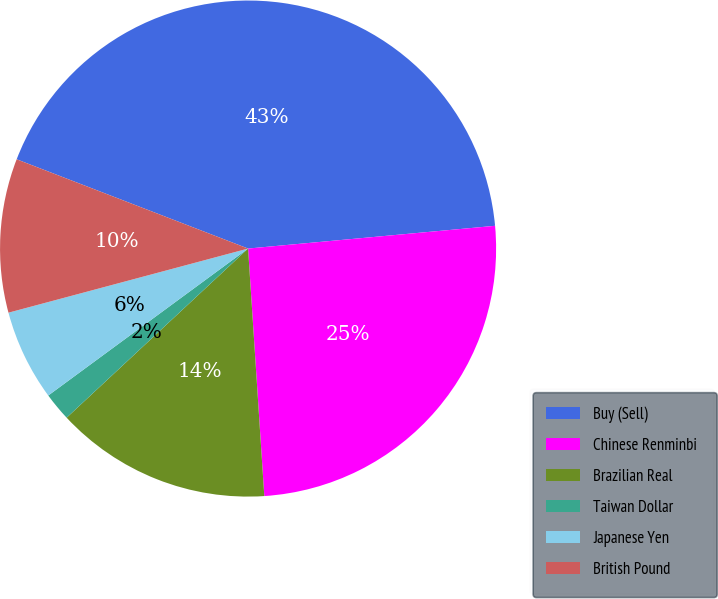Convert chart. <chart><loc_0><loc_0><loc_500><loc_500><pie_chart><fcel>Buy (Sell)<fcel>Chinese Renminbi<fcel>Brazilian Real<fcel>Taiwan Dollar<fcel>Japanese Yen<fcel>British Pound<nl><fcel>42.68%<fcel>25.42%<fcel>14.1%<fcel>1.85%<fcel>5.93%<fcel>10.02%<nl></chart> 